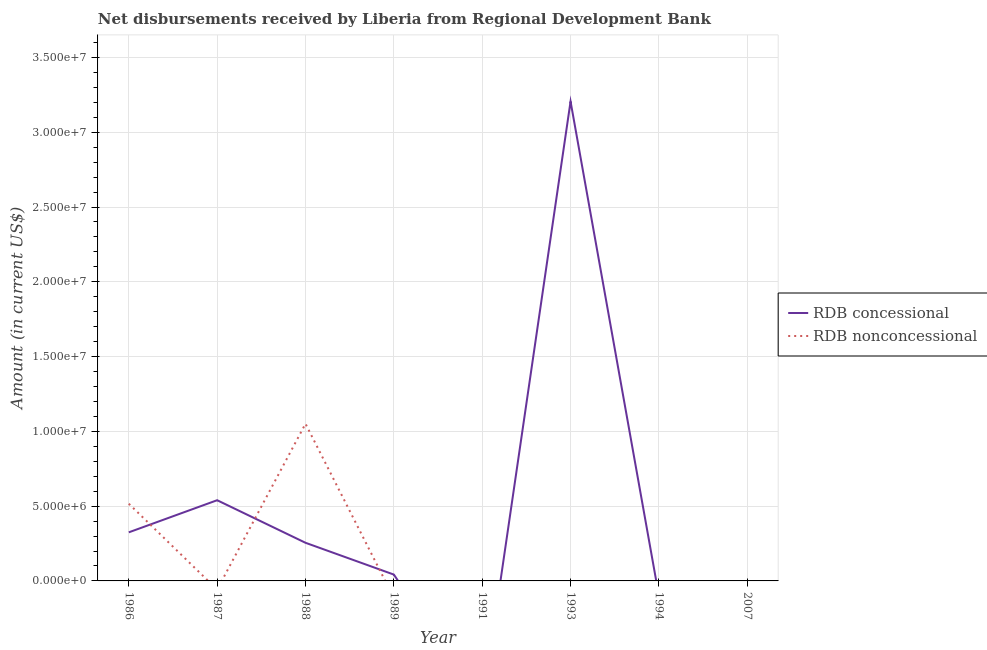How many different coloured lines are there?
Your answer should be compact. 2. What is the net non concessional disbursements from rdb in 1993?
Your response must be concise. 0. Across all years, what is the maximum net non concessional disbursements from rdb?
Your response must be concise. 1.05e+07. In which year was the net non concessional disbursements from rdb maximum?
Your answer should be very brief. 1988. What is the total net non concessional disbursements from rdb in the graph?
Ensure brevity in your answer.  1.57e+07. What is the difference between the net concessional disbursements from rdb in 1986 and that in 1988?
Keep it short and to the point. 6.99e+05. What is the difference between the net non concessional disbursements from rdb in 1993 and the net concessional disbursements from rdb in 2007?
Keep it short and to the point. 0. What is the average net non concessional disbursements from rdb per year?
Your answer should be very brief. 1.96e+06. In the year 1988, what is the difference between the net concessional disbursements from rdb and net non concessional disbursements from rdb?
Give a very brief answer. -7.96e+06. In how many years, is the net non concessional disbursements from rdb greater than 32000000 US$?
Offer a very short reply. 0. Is the net concessional disbursements from rdb in 1987 less than that in 1988?
Offer a very short reply. No. What is the difference between the highest and the second highest net concessional disbursements from rdb?
Keep it short and to the point. 2.67e+07. What is the difference between the highest and the lowest net non concessional disbursements from rdb?
Make the answer very short. 1.05e+07. Is the sum of the net concessional disbursements from rdb in 1986 and 1993 greater than the maximum net non concessional disbursements from rdb across all years?
Your answer should be very brief. Yes. Does the net concessional disbursements from rdb monotonically increase over the years?
Your answer should be compact. No. How many years are there in the graph?
Keep it short and to the point. 8. Are the values on the major ticks of Y-axis written in scientific E-notation?
Provide a short and direct response. Yes. Does the graph contain any zero values?
Offer a terse response. Yes. How many legend labels are there?
Offer a terse response. 2. How are the legend labels stacked?
Ensure brevity in your answer.  Vertical. What is the title of the graph?
Provide a short and direct response. Net disbursements received by Liberia from Regional Development Bank. Does "Girls" appear as one of the legend labels in the graph?
Your answer should be very brief. No. What is the label or title of the X-axis?
Provide a short and direct response. Year. What is the label or title of the Y-axis?
Offer a terse response. Amount (in current US$). What is the Amount (in current US$) in RDB concessional in 1986?
Give a very brief answer. 3.25e+06. What is the Amount (in current US$) of RDB nonconcessional in 1986?
Make the answer very short. 5.16e+06. What is the Amount (in current US$) in RDB concessional in 1987?
Your answer should be very brief. 5.40e+06. What is the Amount (in current US$) of RDB concessional in 1988?
Your response must be concise. 2.55e+06. What is the Amount (in current US$) of RDB nonconcessional in 1988?
Your response must be concise. 1.05e+07. What is the Amount (in current US$) of RDB concessional in 1989?
Provide a succinct answer. 4.24e+05. What is the Amount (in current US$) in RDB nonconcessional in 1989?
Your answer should be very brief. 0. What is the Amount (in current US$) in RDB concessional in 1993?
Offer a terse response. 3.21e+07. What is the Amount (in current US$) in RDB concessional in 1994?
Offer a terse response. 0. What is the Amount (in current US$) of RDB nonconcessional in 1994?
Your answer should be compact. 0. Across all years, what is the maximum Amount (in current US$) in RDB concessional?
Your answer should be very brief. 3.21e+07. Across all years, what is the maximum Amount (in current US$) of RDB nonconcessional?
Your answer should be very brief. 1.05e+07. Across all years, what is the minimum Amount (in current US$) in RDB nonconcessional?
Ensure brevity in your answer.  0. What is the total Amount (in current US$) in RDB concessional in the graph?
Give a very brief answer. 4.37e+07. What is the total Amount (in current US$) in RDB nonconcessional in the graph?
Keep it short and to the point. 1.57e+07. What is the difference between the Amount (in current US$) of RDB concessional in 1986 and that in 1987?
Make the answer very short. -2.15e+06. What is the difference between the Amount (in current US$) in RDB concessional in 1986 and that in 1988?
Ensure brevity in your answer.  6.99e+05. What is the difference between the Amount (in current US$) of RDB nonconcessional in 1986 and that in 1988?
Make the answer very short. -5.35e+06. What is the difference between the Amount (in current US$) in RDB concessional in 1986 and that in 1989?
Give a very brief answer. 2.82e+06. What is the difference between the Amount (in current US$) in RDB concessional in 1986 and that in 1993?
Provide a succinct answer. -2.88e+07. What is the difference between the Amount (in current US$) in RDB concessional in 1987 and that in 1988?
Offer a very short reply. 2.85e+06. What is the difference between the Amount (in current US$) in RDB concessional in 1987 and that in 1989?
Your response must be concise. 4.97e+06. What is the difference between the Amount (in current US$) of RDB concessional in 1987 and that in 1993?
Provide a short and direct response. -2.67e+07. What is the difference between the Amount (in current US$) in RDB concessional in 1988 and that in 1989?
Your answer should be very brief. 2.13e+06. What is the difference between the Amount (in current US$) of RDB concessional in 1988 and that in 1993?
Give a very brief answer. -2.95e+07. What is the difference between the Amount (in current US$) in RDB concessional in 1989 and that in 1993?
Provide a succinct answer. -3.16e+07. What is the difference between the Amount (in current US$) in RDB concessional in 1986 and the Amount (in current US$) in RDB nonconcessional in 1988?
Ensure brevity in your answer.  -7.26e+06. What is the difference between the Amount (in current US$) in RDB concessional in 1987 and the Amount (in current US$) in RDB nonconcessional in 1988?
Provide a succinct answer. -5.11e+06. What is the average Amount (in current US$) in RDB concessional per year?
Make the answer very short. 5.46e+06. What is the average Amount (in current US$) of RDB nonconcessional per year?
Provide a succinct answer. 1.96e+06. In the year 1986, what is the difference between the Amount (in current US$) of RDB concessional and Amount (in current US$) of RDB nonconcessional?
Provide a short and direct response. -1.91e+06. In the year 1988, what is the difference between the Amount (in current US$) in RDB concessional and Amount (in current US$) in RDB nonconcessional?
Your answer should be compact. -7.96e+06. What is the ratio of the Amount (in current US$) in RDB concessional in 1986 to that in 1987?
Keep it short and to the point. 0.6. What is the ratio of the Amount (in current US$) of RDB concessional in 1986 to that in 1988?
Give a very brief answer. 1.27. What is the ratio of the Amount (in current US$) of RDB nonconcessional in 1986 to that in 1988?
Your response must be concise. 0.49. What is the ratio of the Amount (in current US$) in RDB concessional in 1986 to that in 1989?
Offer a very short reply. 7.66. What is the ratio of the Amount (in current US$) of RDB concessional in 1986 to that in 1993?
Provide a short and direct response. 0.1. What is the ratio of the Amount (in current US$) of RDB concessional in 1987 to that in 1988?
Make the answer very short. 2.12. What is the ratio of the Amount (in current US$) of RDB concessional in 1987 to that in 1989?
Your answer should be very brief. 12.73. What is the ratio of the Amount (in current US$) in RDB concessional in 1987 to that in 1993?
Provide a succinct answer. 0.17. What is the ratio of the Amount (in current US$) in RDB concessional in 1988 to that in 1989?
Provide a succinct answer. 6.01. What is the ratio of the Amount (in current US$) in RDB concessional in 1988 to that in 1993?
Keep it short and to the point. 0.08. What is the ratio of the Amount (in current US$) of RDB concessional in 1989 to that in 1993?
Offer a terse response. 0.01. What is the difference between the highest and the second highest Amount (in current US$) of RDB concessional?
Your answer should be very brief. 2.67e+07. What is the difference between the highest and the lowest Amount (in current US$) of RDB concessional?
Your answer should be compact. 3.21e+07. What is the difference between the highest and the lowest Amount (in current US$) in RDB nonconcessional?
Keep it short and to the point. 1.05e+07. 